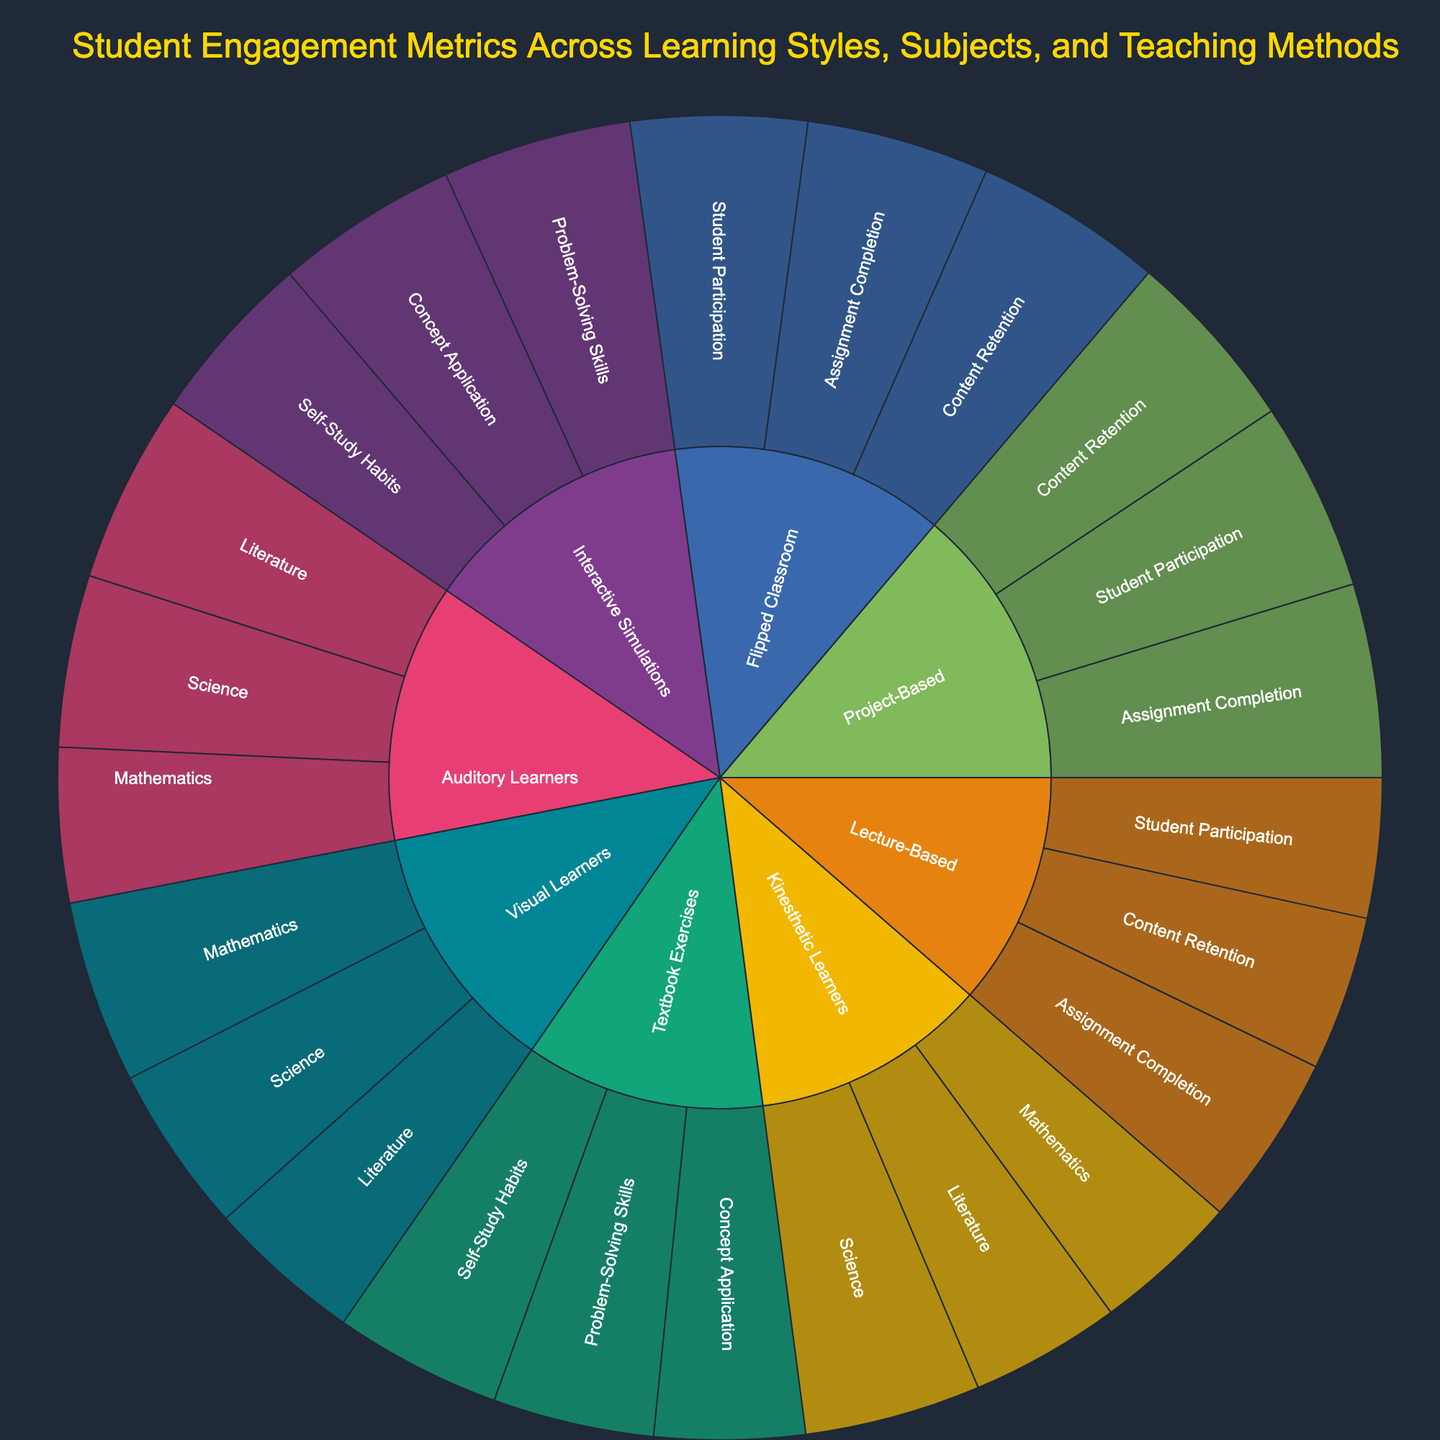What is the title of the figure? You can find the title at the top of the figure.
Answer: Student Engagement Metrics Across Learning Styles, Subjects, and Teaching Methods How many categories are represented in the figure? Count the number of main sections in the sunburst chart, each representing a different category.
Answer: 5 Which learning style has the highest student engagement in Mathematics? Look at the segments under the 'Mathematics' subcategory and compare the engagement values for each learning style. The highest value corresponds to the learning style with the highest engagement.
Answer: Visual Learners What is the total student engagement value for Visual Learners across all subjects? Sum the engagement values for all subcategories under 'Visual Learners'.
Answer: 235 How does student participation in Project-Based teaching compare to that in Lecture-Based teaching? Compare the segments representing 'Student Participation' under 'Project-Based' and 'Lecture-Based' categories by their values.
Answer: Project-Based teaching has higher student participation (88) compared to Lecture-Based teaching (65) Which category has the highest total value when considering Content Retention? Compare the values for 'Content Retention' across all teaching methods and select the highest one.
Answer: Flipped Classroom What is the average value of Assignment Completion across all teaching methods? Sum the assignment completion values for 'Lecture-Based', 'Project-Based', and 'Flipped Classroom' and divide by the number of teaching methods (3).
Answer: 85 [(80 + 90 + 85) / 3] Between Interactive Simulations and Textbook Exercises, which method better improves Concept Application? Compare the values for 'Concept Application' under 'Interactive Simulations' and 'Textbook Exercises'.
Answer: Interactive Simulations What is the difference in the value of Content Retention between Lecture-Based and Project-Based teaching? Subtract the Content Retention value of Lecture-Based teaching from that of Project-Based teaching.
Answer: 13 Which subcategory under Kinesthetic Learners has the lowest student engagement value? Look at the values for each subcategory under 'Kinesthetic Learners' and select the lowest one.
Answer: Mathematics 